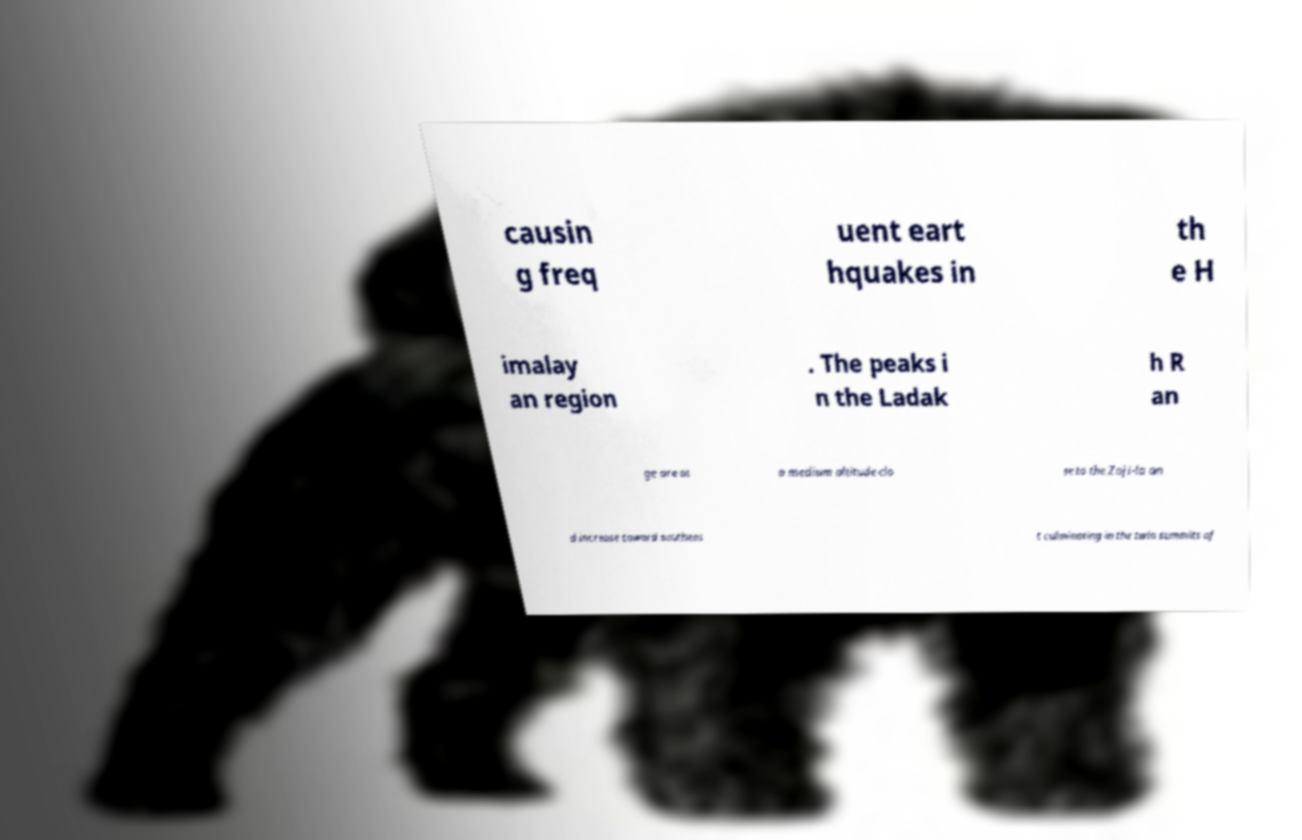Can you accurately transcribe the text from the provided image for me? causin g freq uent eart hquakes in th e H imalay an region . The peaks i n the Ladak h R an ge are at a medium altitude clo se to the Zoji-la an d increase toward southeas t culminating in the twin summits of 